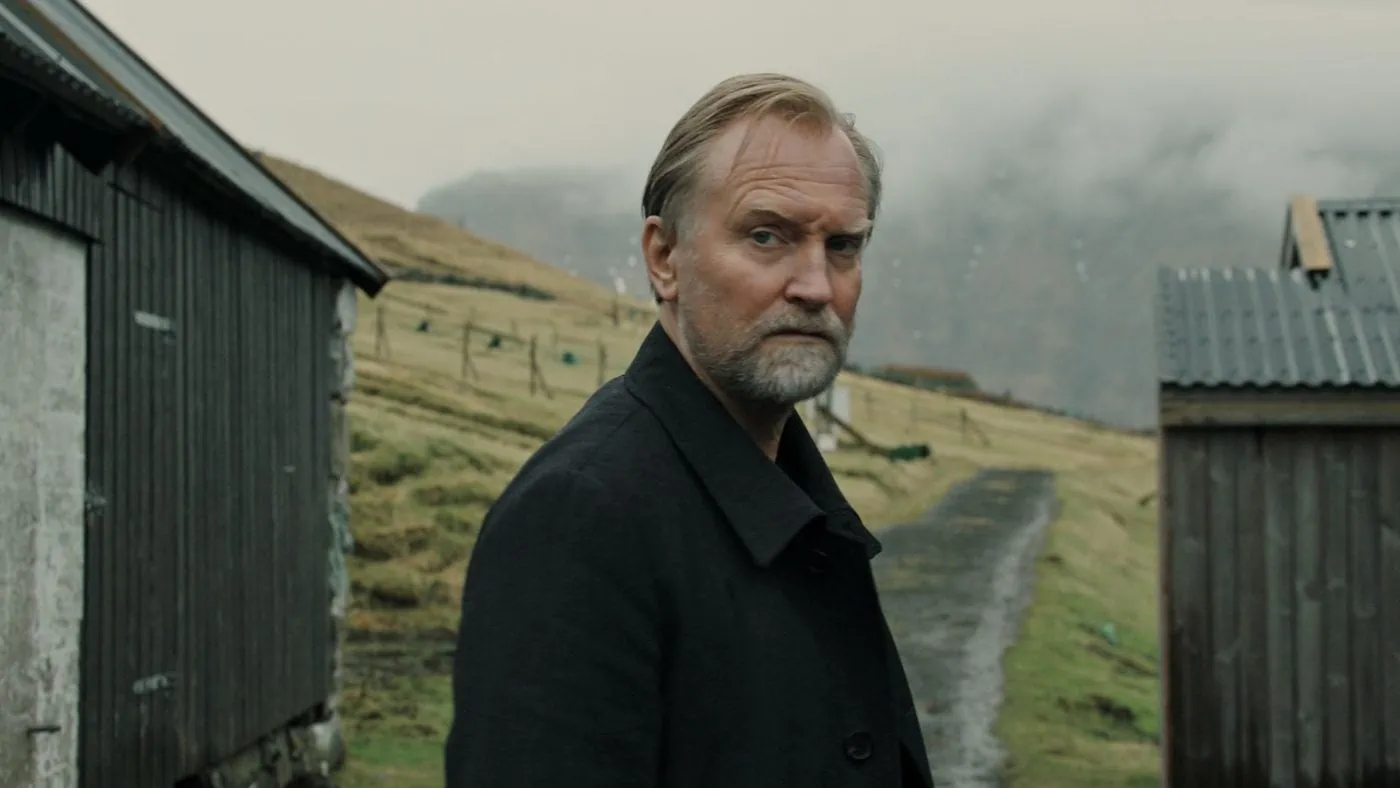If the scene depicted in this image were to come alive, describe the immediate next moment. As the scene depicted in this image comes to life, a gentle breeze rustles through the grass, carrying with it the faint, nostalgic scent of earth and wood. The man, deep in thought, slowly begins to turn his head, as if sensing an unseen presence behind him. His expression shifts subtly, hinting at a mixture of recognition and surprise. In the distance, the muted sound of sheep bleating breaks the silence, merging with the soft murmur of the countryside, completing the sensory tapestry of this tranquil, reflective moment. 